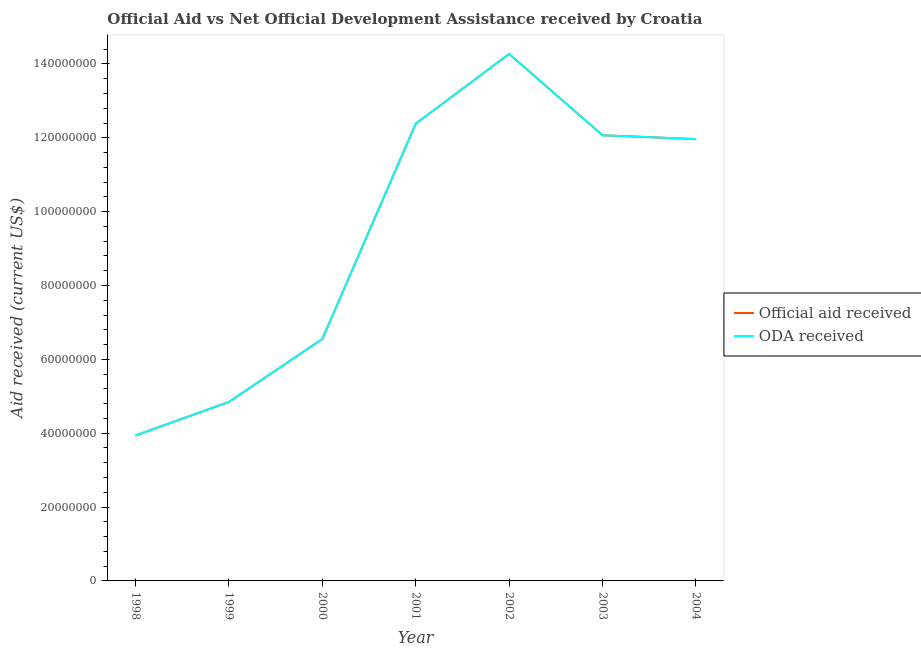How many different coloured lines are there?
Offer a terse response. 2. Is the number of lines equal to the number of legend labels?
Keep it short and to the point. Yes. What is the official aid received in 2001?
Give a very brief answer. 1.24e+08. Across all years, what is the maximum oda received?
Your answer should be compact. 1.43e+08. Across all years, what is the minimum official aid received?
Make the answer very short. 3.94e+07. In which year was the oda received maximum?
Your response must be concise. 2002. In which year was the oda received minimum?
Your answer should be compact. 1998. What is the total oda received in the graph?
Your answer should be compact. 6.60e+08. What is the difference between the oda received in 1999 and that in 2000?
Ensure brevity in your answer.  -1.70e+07. What is the difference between the official aid received in 2004 and the oda received in 1998?
Keep it short and to the point. 8.03e+07. What is the average oda received per year?
Offer a terse response. 9.43e+07. In the year 2000, what is the difference between the oda received and official aid received?
Your answer should be very brief. 0. In how many years, is the oda received greater than 8000000 US$?
Make the answer very short. 7. What is the ratio of the official aid received in 2002 to that in 2003?
Your answer should be very brief. 1.18. Is the difference between the oda received in 2001 and 2002 greater than the difference between the official aid received in 2001 and 2002?
Your answer should be compact. No. What is the difference between the highest and the second highest oda received?
Keep it short and to the point. 1.89e+07. What is the difference between the highest and the lowest official aid received?
Provide a succinct answer. 1.03e+08. Is the sum of the oda received in 1999 and 2003 greater than the maximum official aid received across all years?
Make the answer very short. Yes. Does the official aid received monotonically increase over the years?
Your response must be concise. No. Is the official aid received strictly greater than the oda received over the years?
Your answer should be very brief. No. How many lines are there?
Provide a short and direct response. 2. How many years are there in the graph?
Make the answer very short. 7. Does the graph contain any zero values?
Provide a short and direct response. No. Does the graph contain grids?
Provide a succinct answer. No. How many legend labels are there?
Your response must be concise. 2. What is the title of the graph?
Make the answer very short. Official Aid vs Net Official Development Assistance received by Croatia . What is the label or title of the Y-axis?
Keep it short and to the point. Aid received (current US$). What is the Aid received (current US$) of Official aid received in 1998?
Provide a succinct answer. 3.94e+07. What is the Aid received (current US$) in ODA received in 1998?
Your answer should be very brief. 3.94e+07. What is the Aid received (current US$) of Official aid received in 1999?
Provide a short and direct response. 4.85e+07. What is the Aid received (current US$) of ODA received in 1999?
Your answer should be very brief. 4.85e+07. What is the Aid received (current US$) in Official aid received in 2000?
Make the answer very short. 6.55e+07. What is the Aid received (current US$) in ODA received in 2000?
Offer a terse response. 6.55e+07. What is the Aid received (current US$) in Official aid received in 2001?
Provide a short and direct response. 1.24e+08. What is the Aid received (current US$) of ODA received in 2001?
Your response must be concise. 1.24e+08. What is the Aid received (current US$) of Official aid received in 2002?
Ensure brevity in your answer.  1.43e+08. What is the Aid received (current US$) of ODA received in 2002?
Your answer should be compact. 1.43e+08. What is the Aid received (current US$) in Official aid received in 2003?
Make the answer very short. 1.21e+08. What is the Aid received (current US$) in ODA received in 2003?
Your response must be concise. 1.21e+08. What is the Aid received (current US$) in Official aid received in 2004?
Make the answer very short. 1.20e+08. What is the Aid received (current US$) in ODA received in 2004?
Ensure brevity in your answer.  1.20e+08. Across all years, what is the maximum Aid received (current US$) in Official aid received?
Give a very brief answer. 1.43e+08. Across all years, what is the maximum Aid received (current US$) in ODA received?
Offer a terse response. 1.43e+08. Across all years, what is the minimum Aid received (current US$) of Official aid received?
Keep it short and to the point. 3.94e+07. Across all years, what is the minimum Aid received (current US$) in ODA received?
Keep it short and to the point. 3.94e+07. What is the total Aid received (current US$) of Official aid received in the graph?
Your answer should be compact. 6.60e+08. What is the total Aid received (current US$) in ODA received in the graph?
Ensure brevity in your answer.  6.60e+08. What is the difference between the Aid received (current US$) of Official aid received in 1998 and that in 1999?
Give a very brief answer. -9.09e+06. What is the difference between the Aid received (current US$) in ODA received in 1998 and that in 1999?
Your answer should be compact. -9.09e+06. What is the difference between the Aid received (current US$) in Official aid received in 1998 and that in 2000?
Your answer should be very brief. -2.61e+07. What is the difference between the Aid received (current US$) of ODA received in 1998 and that in 2000?
Ensure brevity in your answer.  -2.61e+07. What is the difference between the Aid received (current US$) in Official aid received in 1998 and that in 2001?
Offer a very short reply. -8.44e+07. What is the difference between the Aid received (current US$) of ODA received in 1998 and that in 2001?
Make the answer very short. -8.44e+07. What is the difference between the Aid received (current US$) in Official aid received in 1998 and that in 2002?
Your response must be concise. -1.03e+08. What is the difference between the Aid received (current US$) in ODA received in 1998 and that in 2002?
Your answer should be compact. -1.03e+08. What is the difference between the Aid received (current US$) of Official aid received in 1998 and that in 2003?
Give a very brief answer. -8.13e+07. What is the difference between the Aid received (current US$) of ODA received in 1998 and that in 2003?
Provide a succinct answer. -8.13e+07. What is the difference between the Aid received (current US$) in Official aid received in 1998 and that in 2004?
Offer a very short reply. -8.03e+07. What is the difference between the Aid received (current US$) of ODA received in 1998 and that in 2004?
Offer a very short reply. -8.03e+07. What is the difference between the Aid received (current US$) of Official aid received in 1999 and that in 2000?
Offer a terse response. -1.70e+07. What is the difference between the Aid received (current US$) of ODA received in 1999 and that in 2000?
Provide a short and direct response. -1.70e+07. What is the difference between the Aid received (current US$) in Official aid received in 1999 and that in 2001?
Provide a succinct answer. -7.53e+07. What is the difference between the Aid received (current US$) in ODA received in 1999 and that in 2001?
Keep it short and to the point. -7.53e+07. What is the difference between the Aid received (current US$) in Official aid received in 1999 and that in 2002?
Your response must be concise. -9.42e+07. What is the difference between the Aid received (current US$) in ODA received in 1999 and that in 2002?
Provide a succinct answer. -9.42e+07. What is the difference between the Aid received (current US$) in Official aid received in 1999 and that in 2003?
Offer a very short reply. -7.22e+07. What is the difference between the Aid received (current US$) in ODA received in 1999 and that in 2003?
Provide a succinct answer. -7.22e+07. What is the difference between the Aid received (current US$) of Official aid received in 1999 and that in 2004?
Provide a short and direct response. -7.12e+07. What is the difference between the Aid received (current US$) in ODA received in 1999 and that in 2004?
Give a very brief answer. -7.12e+07. What is the difference between the Aid received (current US$) in Official aid received in 2000 and that in 2001?
Your answer should be very brief. -5.83e+07. What is the difference between the Aid received (current US$) in ODA received in 2000 and that in 2001?
Keep it short and to the point. -5.83e+07. What is the difference between the Aid received (current US$) in Official aid received in 2000 and that in 2002?
Your response must be concise. -7.72e+07. What is the difference between the Aid received (current US$) in ODA received in 2000 and that in 2002?
Give a very brief answer. -7.72e+07. What is the difference between the Aid received (current US$) of Official aid received in 2000 and that in 2003?
Your answer should be compact. -5.52e+07. What is the difference between the Aid received (current US$) in ODA received in 2000 and that in 2003?
Offer a terse response. -5.52e+07. What is the difference between the Aid received (current US$) of Official aid received in 2000 and that in 2004?
Give a very brief answer. -5.42e+07. What is the difference between the Aid received (current US$) of ODA received in 2000 and that in 2004?
Keep it short and to the point. -5.42e+07. What is the difference between the Aid received (current US$) of Official aid received in 2001 and that in 2002?
Make the answer very short. -1.89e+07. What is the difference between the Aid received (current US$) of ODA received in 2001 and that in 2002?
Make the answer very short. -1.89e+07. What is the difference between the Aid received (current US$) in Official aid received in 2001 and that in 2003?
Offer a very short reply. 3.11e+06. What is the difference between the Aid received (current US$) of ODA received in 2001 and that in 2003?
Your answer should be compact. 3.11e+06. What is the difference between the Aid received (current US$) in Official aid received in 2001 and that in 2004?
Offer a terse response. 4.15e+06. What is the difference between the Aid received (current US$) in ODA received in 2001 and that in 2004?
Keep it short and to the point. 4.15e+06. What is the difference between the Aid received (current US$) of Official aid received in 2002 and that in 2003?
Your answer should be very brief. 2.20e+07. What is the difference between the Aid received (current US$) of ODA received in 2002 and that in 2003?
Your response must be concise. 2.20e+07. What is the difference between the Aid received (current US$) in Official aid received in 2002 and that in 2004?
Your answer should be very brief. 2.31e+07. What is the difference between the Aid received (current US$) of ODA received in 2002 and that in 2004?
Provide a succinct answer. 2.31e+07. What is the difference between the Aid received (current US$) in Official aid received in 2003 and that in 2004?
Keep it short and to the point. 1.04e+06. What is the difference between the Aid received (current US$) in ODA received in 2003 and that in 2004?
Your answer should be very brief. 1.04e+06. What is the difference between the Aid received (current US$) in Official aid received in 1998 and the Aid received (current US$) in ODA received in 1999?
Your answer should be compact. -9.09e+06. What is the difference between the Aid received (current US$) in Official aid received in 1998 and the Aid received (current US$) in ODA received in 2000?
Your response must be concise. -2.61e+07. What is the difference between the Aid received (current US$) in Official aid received in 1998 and the Aid received (current US$) in ODA received in 2001?
Provide a short and direct response. -8.44e+07. What is the difference between the Aid received (current US$) of Official aid received in 1998 and the Aid received (current US$) of ODA received in 2002?
Your answer should be compact. -1.03e+08. What is the difference between the Aid received (current US$) of Official aid received in 1998 and the Aid received (current US$) of ODA received in 2003?
Make the answer very short. -8.13e+07. What is the difference between the Aid received (current US$) in Official aid received in 1998 and the Aid received (current US$) in ODA received in 2004?
Ensure brevity in your answer.  -8.03e+07. What is the difference between the Aid received (current US$) in Official aid received in 1999 and the Aid received (current US$) in ODA received in 2000?
Offer a terse response. -1.70e+07. What is the difference between the Aid received (current US$) in Official aid received in 1999 and the Aid received (current US$) in ODA received in 2001?
Provide a short and direct response. -7.53e+07. What is the difference between the Aid received (current US$) of Official aid received in 1999 and the Aid received (current US$) of ODA received in 2002?
Offer a terse response. -9.42e+07. What is the difference between the Aid received (current US$) in Official aid received in 1999 and the Aid received (current US$) in ODA received in 2003?
Provide a short and direct response. -7.22e+07. What is the difference between the Aid received (current US$) of Official aid received in 1999 and the Aid received (current US$) of ODA received in 2004?
Give a very brief answer. -7.12e+07. What is the difference between the Aid received (current US$) in Official aid received in 2000 and the Aid received (current US$) in ODA received in 2001?
Your answer should be very brief. -5.83e+07. What is the difference between the Aid received (current US$) in Official aid received in 2000 and the Aid received (current US$) in ODA received in 2002?
Offer a very short reply. -7.72e+07. What is the difference between the Aid received (current US$) of Official aid received in 2000 and the Aid received (current US$) of ODA received in 2003?
Ensure brevity in your answer.  -5.52e+07. What is the difference between the Aid received (current US$) of Official aid received in 2000 and the Aid received (current US$) of ODA received in 2004?
Your answer should be compact. -5.42e+07. What is the difference between the Aid received (current US$) in Official aid received in 2001 and the Aid received (current US$) in ODA received in 2002?
Offer a terse response. -1.89e+07. What is the difference between the Aid received (current US$) of Official aid received in 2001 and the Aid received (current US$) of ODA received in 2003?
Offer a terse response. 3.11e+06. What is the difference between the Aid received (current US$) of Official aid received in 2001 and the Aid received (current US$) of ODA received in 2004?
Ensure brevity in your answer.  4.15e+06. What is the difference between the Aid received (current US$) of Official aid received in 2002 and the Aid received (current US$) of ODA received in 2003?
Your answer should be compact. 2.20e+07. What is the difference between the Aid received (current US$) in Official aid received in 2002 and the Aid received (current US$) in ODA received in 2004?
Ensure brevity in your answer.  2.31e+07. What is the difference between the Aid received (current US$) in Official aid received in 2003 and the Aid received (current US$) in ODA received in 2004?
Keep it short and to the point. 1.04e+06. What is the average Aid received (current US$) in Official aid received per year?
Your response must be concise. 9.43e+07. What is the average Aid received (current US$) of ODA received per year?
Make the answer very short. 9.43e+07. In the year 2000, what is the difference between the Aid received (current US$) in Official aid received and Aid received (current US$) in ODA received?
Offer a terse response. 0. In the year 2001, what is the difference between the Aid received (current US$) of Official aid received and Aid received (current US$) of ODA received?
Provide a succinct answer. 0. In the year 2004, what is the difference between the Aid received (current US$) in Official aid received and Aid received (current US$) in ODA received?
Your answer should be compact. 0. What is the ratio of the Aid received (current US$) of Official aid received in 1998 to that in 1999?
Ensure brevity in your answer.  0.81. What is the ratio of the Aid received (current US$) in ODA received in 1998 to that in 1999?
Give a very brief answer. 0.81. What is the ratio of the Aid received (current US$) in Official aid received in 1998 to that in 2000?
Provide a short and direct response. 0.6. What is the ratio of the Aid received (current US$) in ODA received in 1998 to that in 2000?
Ensure brevity in your answer.  0.6. What is the ratio of the Aid received (current US$) in Official aid received in 1998 to that in 2001?
Your answer should be compact. 0.32. What is the ratio of the Aid received (current US$) in ODA received in 1998 to that in 2001?
Your answer should be very brief. 0.32. What is the ratio of the Aid received (current US$) of Official aid received in 1998 to that in 2002?
Make the answer very short. 0.28. What is the ratio of the Aid received (current US$) of ODA received in 1998 to that in 2002?
Provide a short and direct response. 0.28. What is the ratio of the Aid received (current US$) in Official aid received in 1998 to that in 2003?
Ensure brevity in your answer.  0.33. What is the ratio of the Aid received (current US$) in ODA received in 1998 to that in 2003?
Provide a succinct answer. 0.33. What is the ratio of the Aid received (current US$) in Official aid received in 1998 to that in 2004?
Provide a short and direct response. 0.33. What is the ratio of the Aid received (current US$) of ODA received in 1998 to that in 2004?
Offer a terse response. 0.33. What is the ratio of the Aid received (current US$) of Official aid received in 1999 to that in 2000?
Your answer should be very brief. 0.74. What is the ratio of the Aid received (current US$) of ODA received in 1999 to that in 2000?
Offer a very short reply. 0.74. What is the ratio of the Aid received (current US$) of Official aid received in 1999 to that in 2001?
Provide a succinct answer. 0.39. What is the ratio of the Aid received (current US$) of ODA received in 1999 to that in 2001?
Provide a succinct answer. 0.39. What is the ratio of the Aid received (current US$) of Official aid received in 1999 to that in 2002?
Your response must be concise. 0.34. What is the ratio of the Aid received (current US$) of ODA received in 1999 to that in 2002?
Your answer should be very brief. 0.34. What is the ratio of the Aid received (current US$) of Official aid received in 1999 to that in 2003?
Keep it short and to the point. 0.4. What is the ratio of the Aid received (current US$) in ODA received in 1999 to that in 2003?
Ensure brevity in your answer.  0.4. What is the ratio of the Aid received (current US$) of Official aid received in 1999 to that in 2004?
Ensure brevity in your answer.  0.41. What is the ratio of the Aid received (current US$) of ODA received in 1999 to that in 2004?
Offer a terse response. 0.41. What is the ratio of the Aid received (current US$) in Official aid received in 2000 to that in 2001?
Offer a very short reply. 0.53. What is the ratio of the Aid received (current US$) in ODA received in 2000 to that in 2001?
Your answer should be compact. 0.53. What is the ratio of the Aid received (current US$) of Official aid received in 2000 to that in 2002?
Make the answer very short. 0.46. What is the ratio of the Aid received (current US$) in ODA received in 2000 to that in 2002?
Your answer should be compact. 0.46. What is the ratio of the Aid received (current US$) of Official aid received in 2000 to that in 2003?
Ensure brevity in your answer.  0.54. What is the ratio of the Aid received (current US$) of ODA received in 2000 to that in 2003?
Provide a short and direct response. 0.54. What is the ratio of the Aid received (current US$) in Official aid received in 2000 to that in 2004?
Offer a terse response. 0.55. What is the ratio of the Aid received (current US$) in ODA received in 2000 to that in 2004?
Make the answer very short. 0.55. What is the ratio of the Aid received (current US$) of Official aid received in 2001 to that in 2002?
Offer a very short reply. 0.87. What is the ratio of the Aid received (current US$) in ODA received in 2001 to that in 2002?
Provide a short and direct response. 0.87. What is the ratio of the Aid received (current US$) of Official aid received in 2001 to that in 2003?
Offer a very short reply. 1.03. What is the ratio of the Aid received (current US$) of ODA received in 2001 to that in 2003?
Offer a very short reply. 1.03. What is the ratio of the Aid received (current US$) of Official aid received in 2001 to that in 2004?
Your answer should be very brief. 1.03. What is the ratio of the Aid received (current US$) of ODA received in 2001 to that in 2004?
Offer a terse response. 1.03. What is the ratio of the Aid received (current US$) of Official aid received in 2002 to that in 2003?
Your answer should be compact. 1.18. What is the ratio of the Aid received (current US$) of ODA received in 2002 to that in 2003?
Provide a short and direct response. 1.18. What is the ratio of the Aid received (current US$) in Official aid received in 2002 to that in 2004?
Offer a terse response. 1.19. What is the ratio of the Aid received (current US$) in ODA received in 2002 to that in 2004?
Ensure brevity in your answer.  1.19. What is the ratio of the Aid received (current US$) in Official aid received in 2003 to that in 2004?
Your response must be concise. 1.01. What is the ratio of the Aid received (current US$) of ODA received in 2003 to that in 2004?
Make the answer very short. 1.01. What is the difference between the highest and the second highest Aid received (current US$) in Official aid received?
Offer a terse response. 1.89e+07. What is the difference between the highest and the second highest Aid received (current US$) in ODA received?
Offer a very short reply. 1.89e+07. What is the difference between the highest and the lowest Aid received (current US$) of Official aid received?
Your response must be concise. 1.03e+08. What is the difference between the highest and the lowest Aid received (current US$) of ODA received?
Your response must be concise. 1.03e+08. 